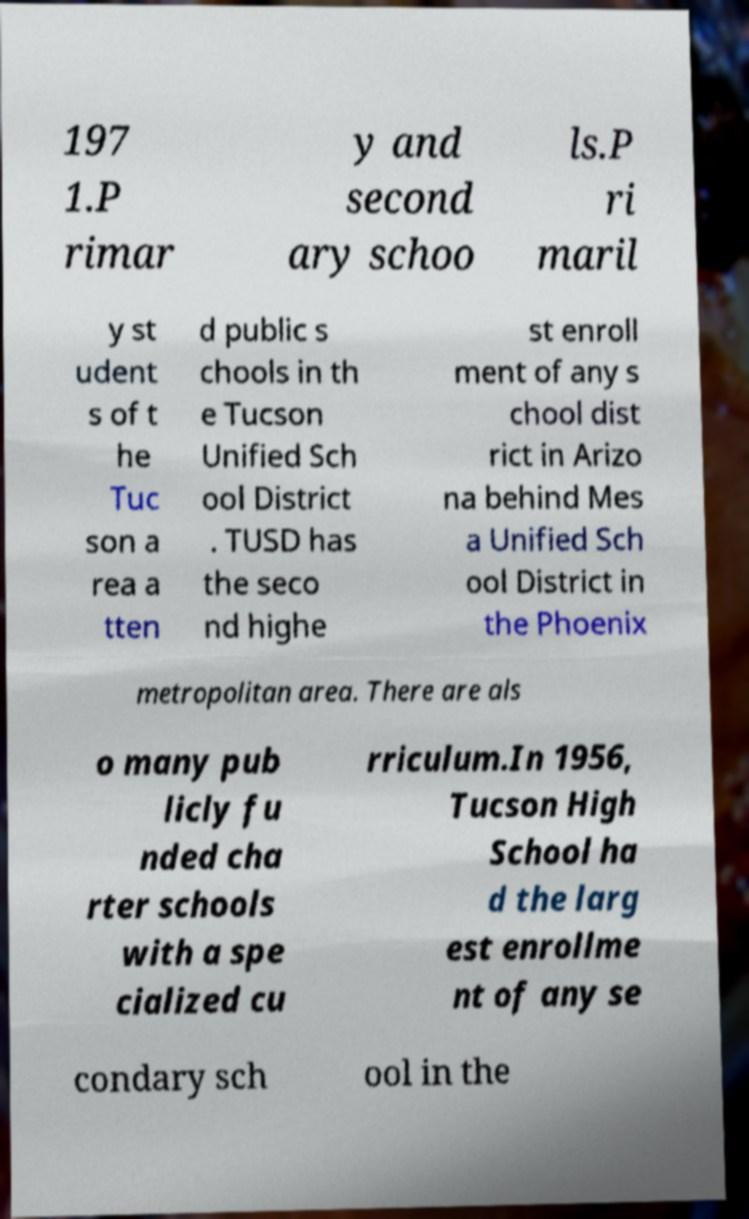There's text embedded in this image that I need extracted. Can you transcribe it verbatim? 197 1.P rimar y and second ary schoo ls.P ri maril y st udent s of t he Tuc son a rea a tten d public s chools in th e Tucson Unified Sch ool District . TUSD has the seco nd highe st enroll ment of any s chool dist rict in Arizo na behind Mes a Unified Sch ool District in the Phoenix metropolitan area. There are als o many pub licly fu nded cha rter schools with a spe cialized cu rriculum.In 1956, Tucson High School ha d the larg est enrollme nt of any se condary sch ool in the 